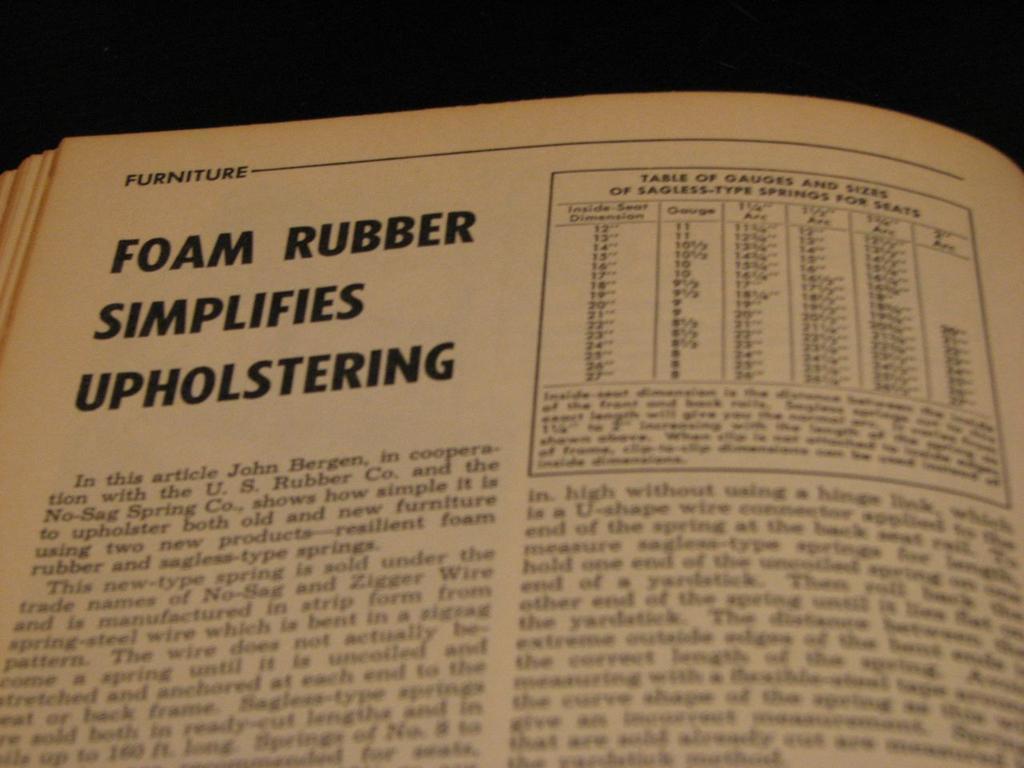Is the player putting on a helmet?
Your response must be concise. Unanswerable. What are the rubber simplifers made of?
Make the answer very short. Foam. 